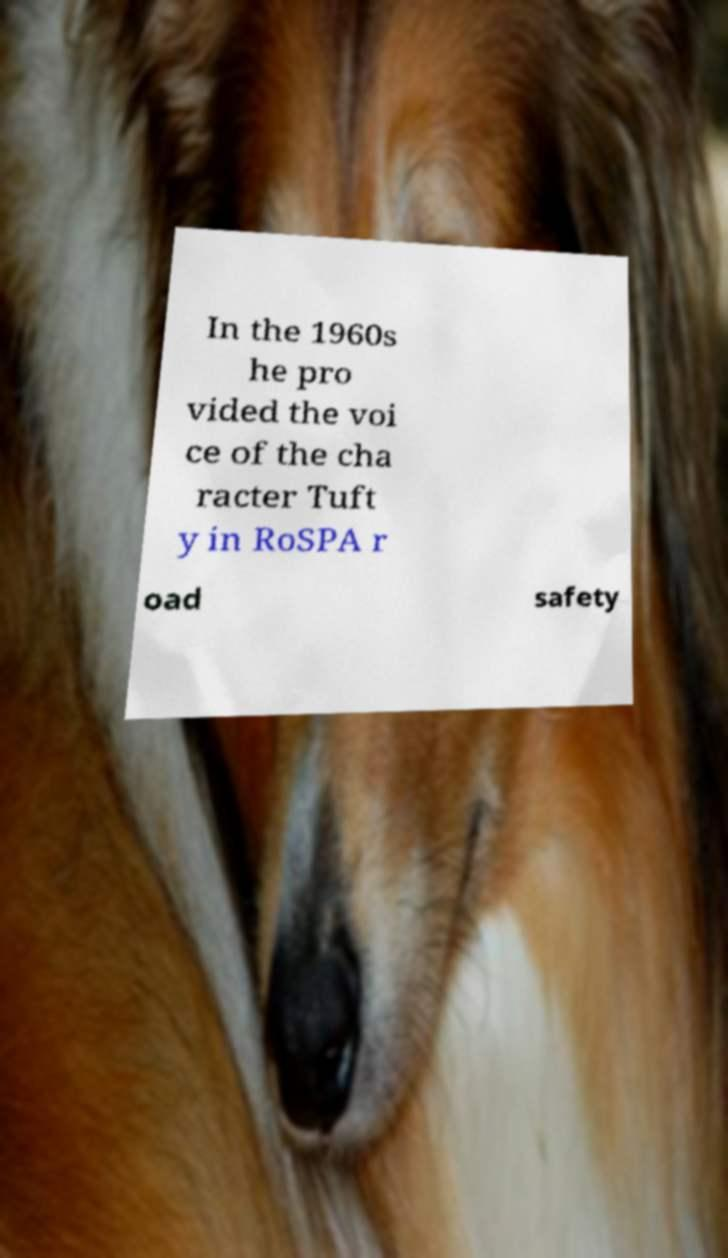I need the written content from this picture converted into text. Can you do that? In the 1960s he pro vided the voi ce of the cha racter Tuft y in RoSPA r oad safety 